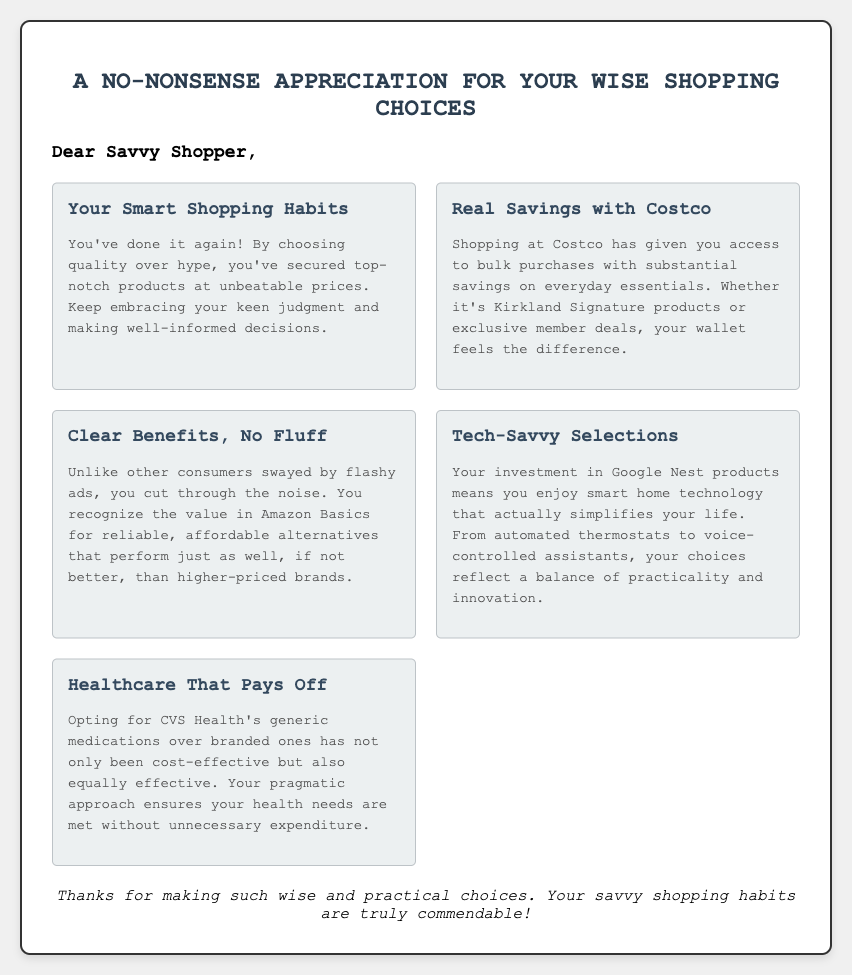What is the greeting card's title? The title of the greeting card is prominently displayed at the top, summarizing its theme.
Answer: A No-Nonsense Appreciation for Your Wise Shopping Choices Who is the greeting card addressed to? The greeting card directly refers to its recipient in the opening message.
Answer: Savvy Shopper What brand is mentioned as promoting bulk savings? The card highlights a specific retailer known for bulk purchases and savings on essentials.
Answer: Costco Which product line is noted for being reliable at lower prices? The card mentions a budget-friendly product line that competes with higher-priced brands.
Answer: Amazon Basics What type of technology is discussed in the context of smart home products? The document references a specific company's product line that focuses on home automation and voice control.
Answer: Google Nest What is the benefit of choosing CVS Health's generic medications? The card emphasizes a cost-saving aspect of selecting a specific type of medication.
Answer: Cost-effective and equally effective How does the card describe the shopper's approach to advertisements? The document notes a distinguishing feature of the shopper's mindset regarding marketing.
Answer: Cuts through the noise What does the closing statement express? The final message conveys appreciation for the recipient's actions highlighted throughout the card.
Answer: Thanks for making such wise and practical choices 